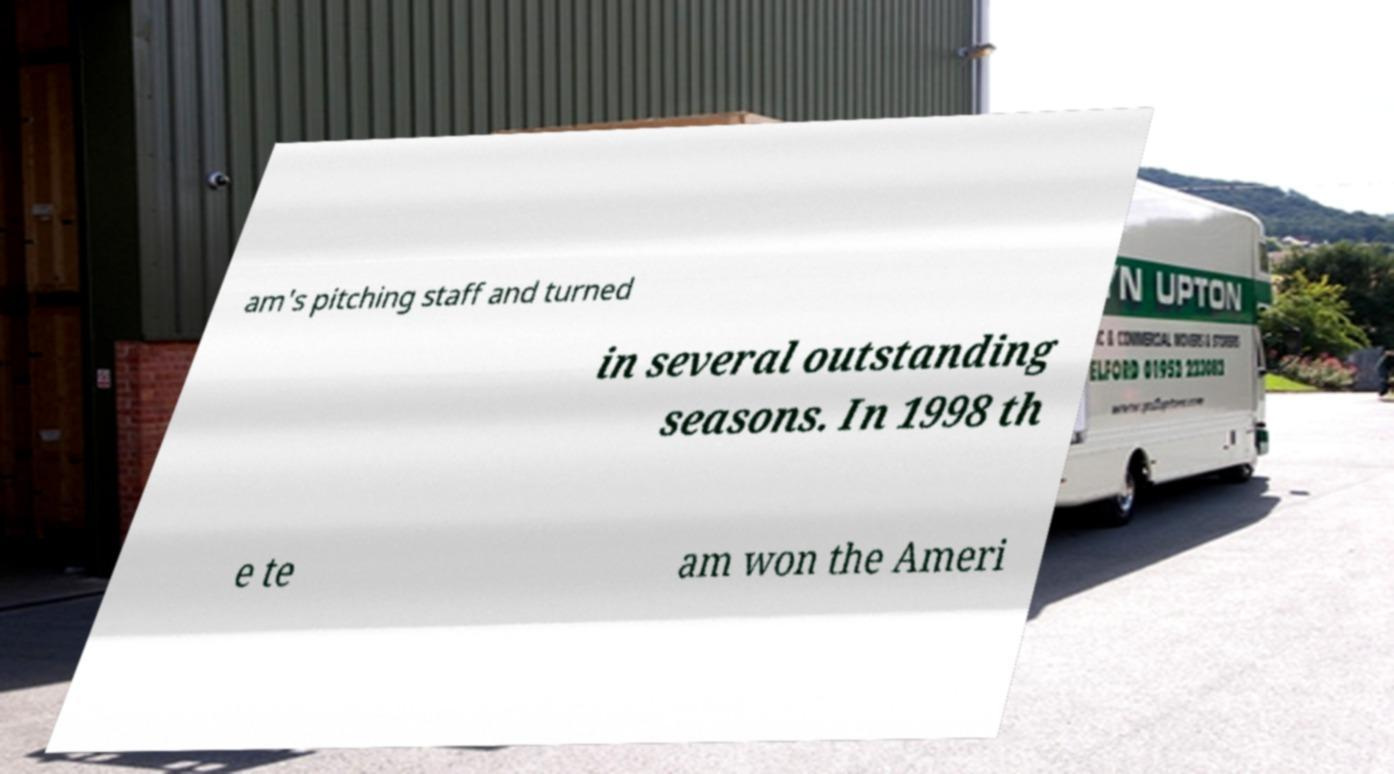Could you assist in decoding the text presented in this image and type it out clearly? am's pitching staff and turned in several outstanding seasons. In 1998 th e te am won the Ameri 